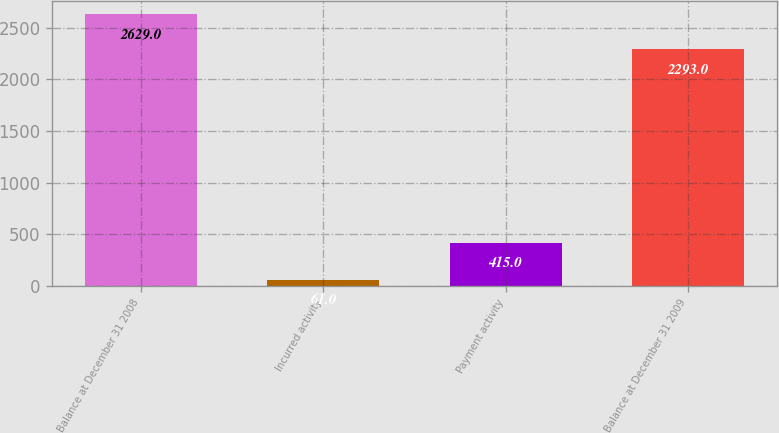Convert chart to OTSL. <chart><loc_0><loc_0><loc_500><loc_500><bar_chart><fcel>Balance at December 31 2008<fcel>Incurred activity<fcel>Payment activity<fcel>Balance at December 31 2009<nl><fcel>2629<fcel>61<fcel>415<fcel>2293<nl></chart> 